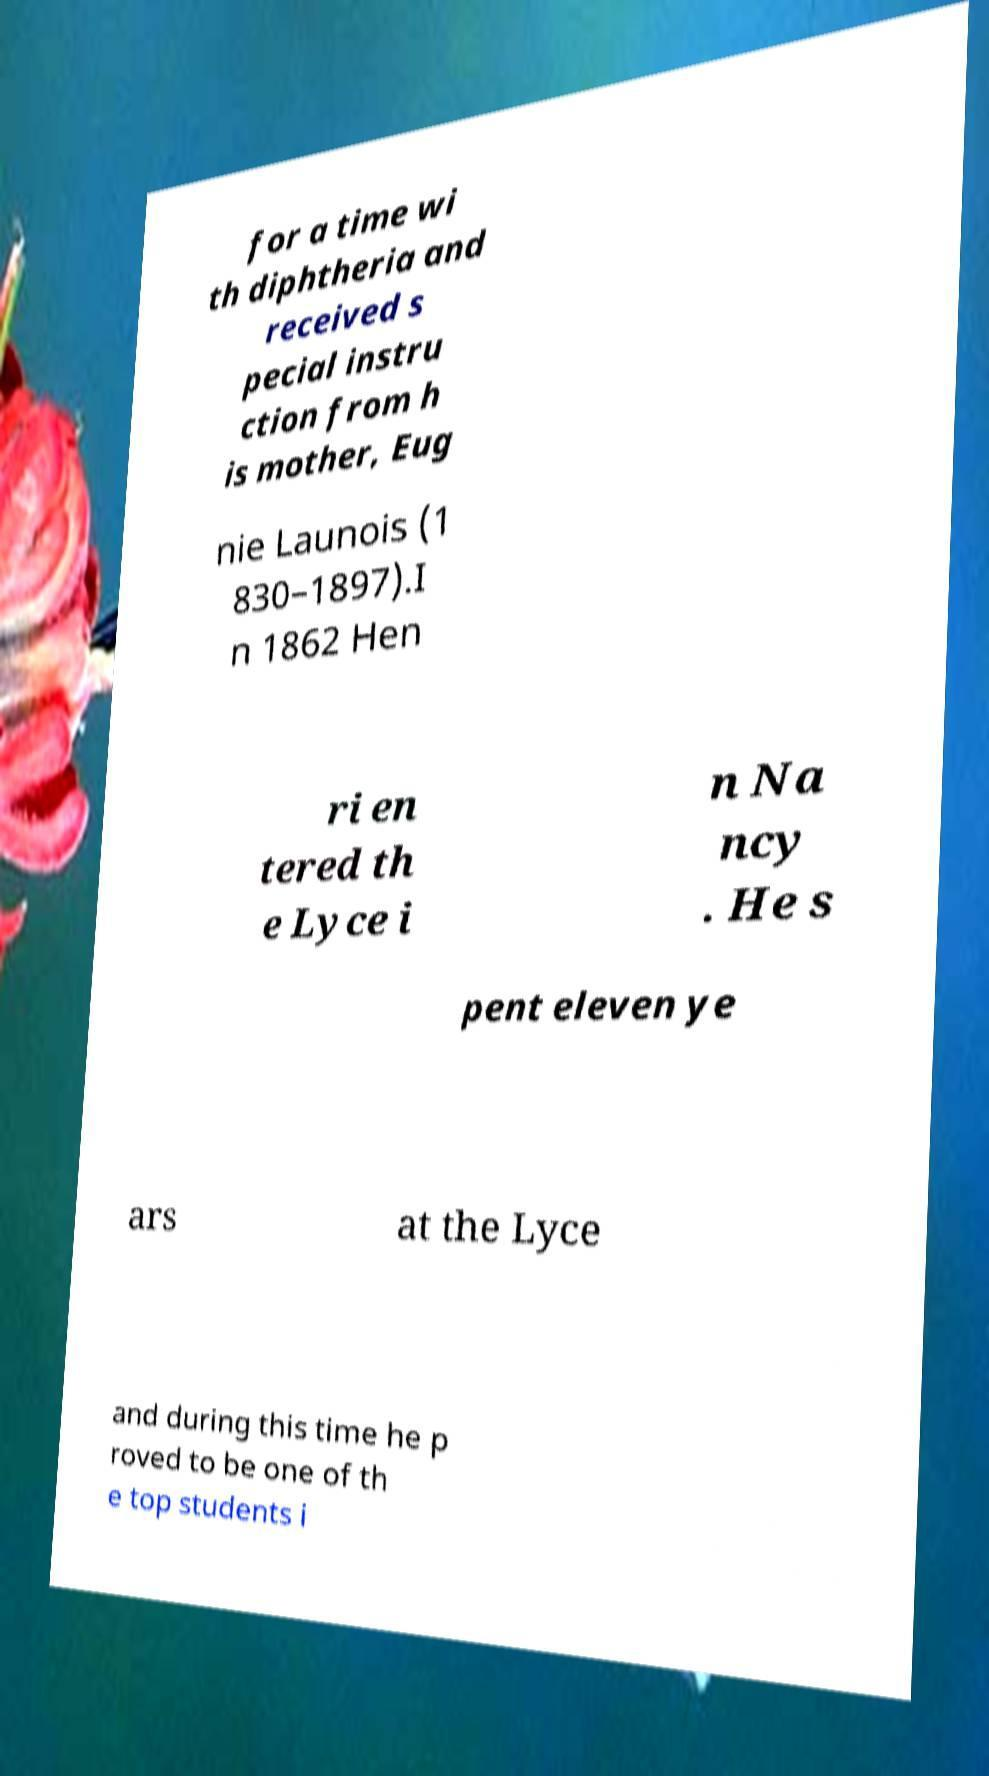What messages or text are displayed in this image? I need them in a readable, typed format. for a time wi th diphtheria and received s pecial instru ction from h is mother, Eug nie Launois (1 830–1897).I n 1862 Hen ri en tered th e Lyce i n Na ncy . He s pent eleven ye ars at the Lyce and during this time he p roved to be one of th e top students i 